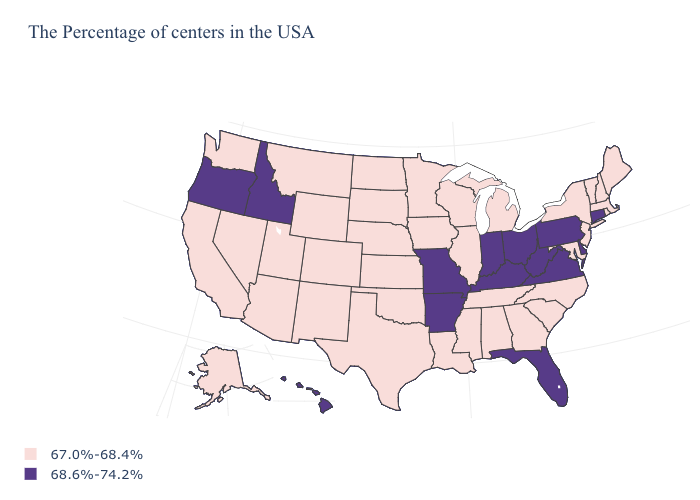Does Virginia have the highest value in the USA?
Keep it brief. Yes. Name the states that have a value in the range 68.6%-74.2%?
Quick response, please. Connecticut, Delaware, Pennsylvania, Virginia, West Virginia, Ohio, Florida, Kentucky, Indiana, Missouri, Arkansas, Idaho, Oregon, Hawaii. Name the states that have a value in the range 68.6%-74.2%?
Keep it brief. Connecticut, Delaware, Pennsylvania, Virginia, West Virginia, Ohio, Florida, Kentucky, Indiana, Missouri, Arkansas, Idaho, Oregon, Hawaii. What is the value of Iowa?
Be succinct. 67.0%-68.4%. Name the states that have a value in the range 67.0%-68.4%?
Answer briefly. Maine, Massachusetts, Rhode Island, New Hampshire, Vermont, New York, New Jersey, Maryland, North Carolina, South Carolina, Georgia, Michigan, Alabama, Tennessee, Wisconsin, Illinois, Mississippi, Louisiana, Minnesota, Iowa, Kansas, Nebraska, Oklahoma, Texas, South Dakota, North Dakota, Wyoming, Colorado, New Mexico, Utah, Montana, Arizona, Nevada, California, Washington, Alaska. Does Georgia have a higher value than Washington?
Quick response, please. No. Does New Jersey have the highest value in the Northeast?
Quick response, please. No. Does the first symbol in the legend represent the smallest category?
Keep it brief. Yes. What is the value of Montana?
Give a very brief answer. 67.0%-68.4%. What is the highest value in the Northeast ?
Be succinct. 68.6%-74.2%. What is the lowest value in states that border Oklahoma?
Concise answer only. 67.0%-68.4%. Name the states that have a value in the range 68.6%-74.2%?
Answer briefly. Connecticut, Delaware, Pennsylvania, Virginia, West Virginia, Ohio, Florida, Kentucky, Indiana, Missouri, Arkansas, Idaho, Oregon, Hawaii. Name the states that have a value in the range 67.0%-68.4%?
Quick response, please. Maine, Massachusetts, Rhode Island, New Hampshire, Vermont, New York, New Jersey, Maryland, North Carolina, South Carolina, Georgia, Michigan, Alabama, Tennessee, Wisconsin, Illinois, Mississippi, Louisiana, Minnesota, Iowa, Kansas, Nebraska, Oklahoma, Texas, South Dakota, North Dakota, Wyoming, Colorado, New Mexico, Utah, Montana, Arizona, Nevada, California, Washington, Alaska. Does Wyoming have the lowest value in the USA?
Be succinct. Yes. 